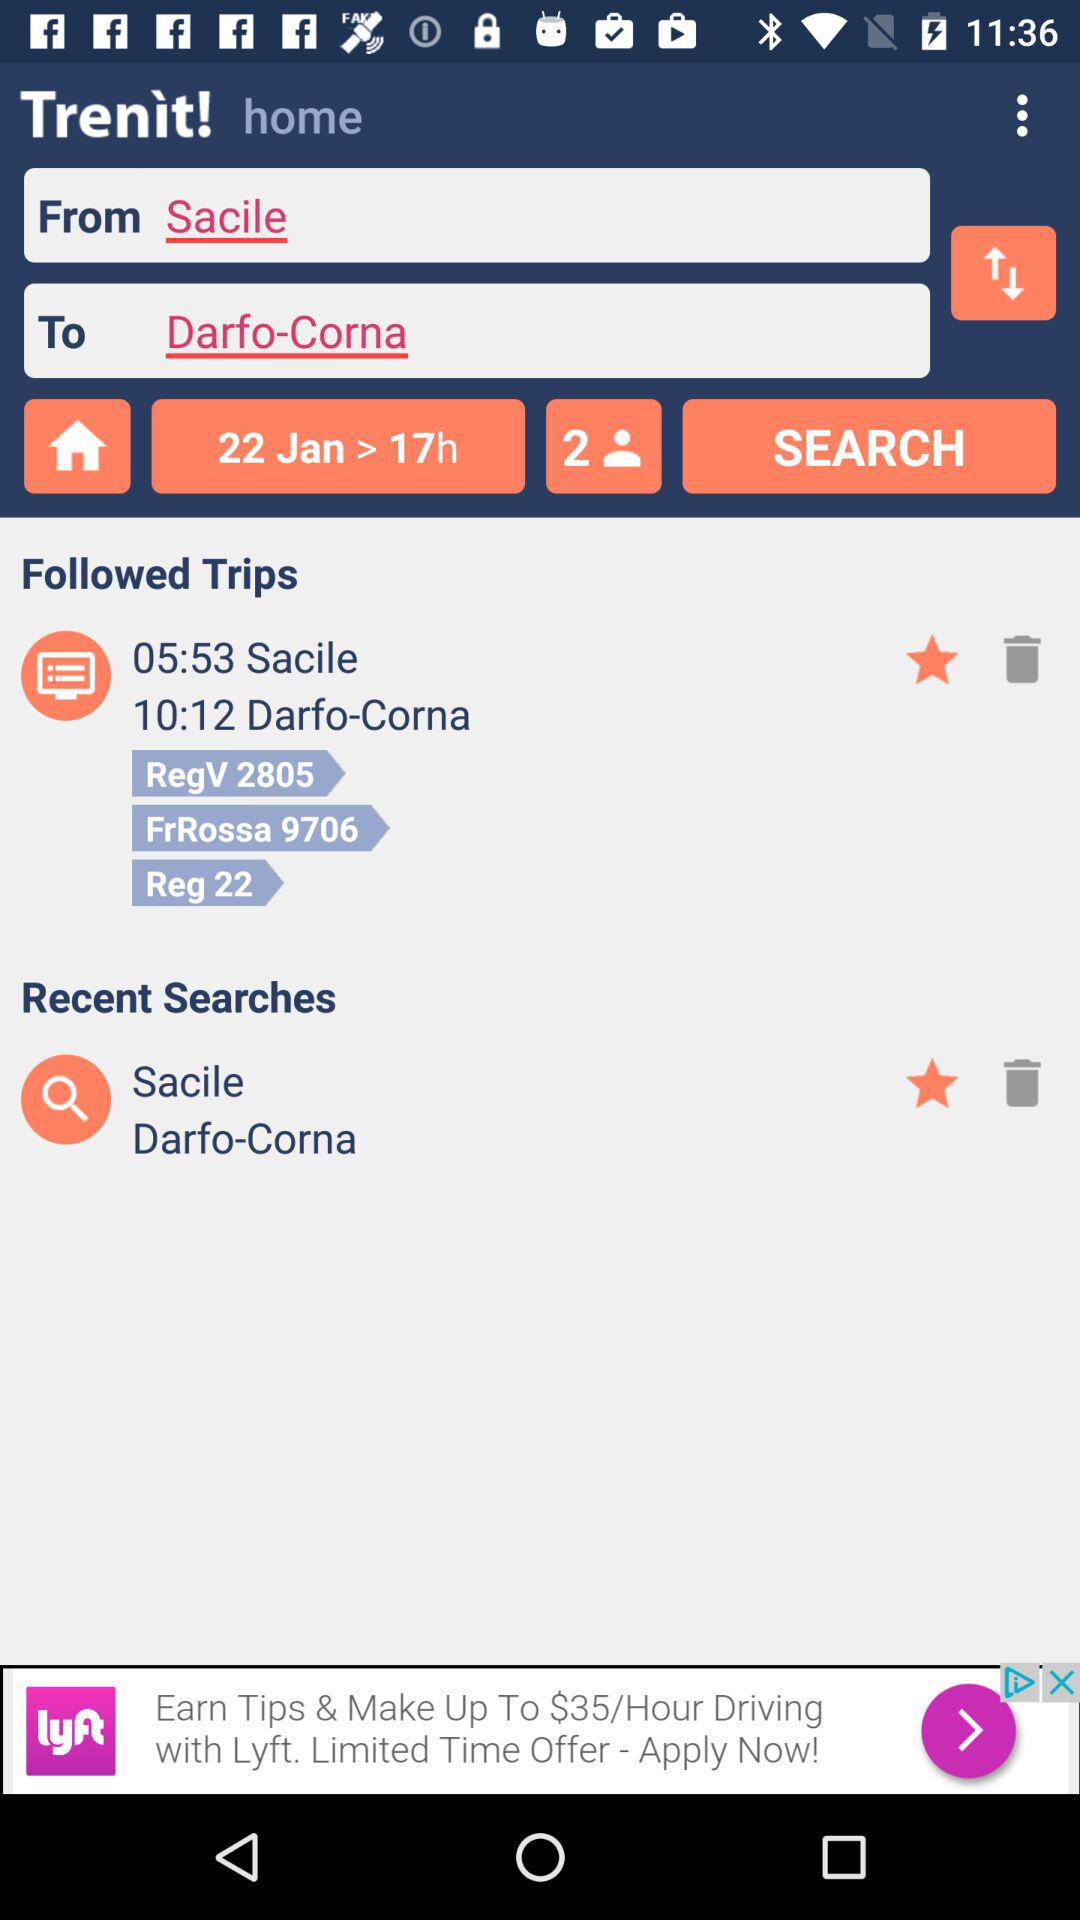For how many people is the booking process in progress? The booking process is in progress for 2 people. 